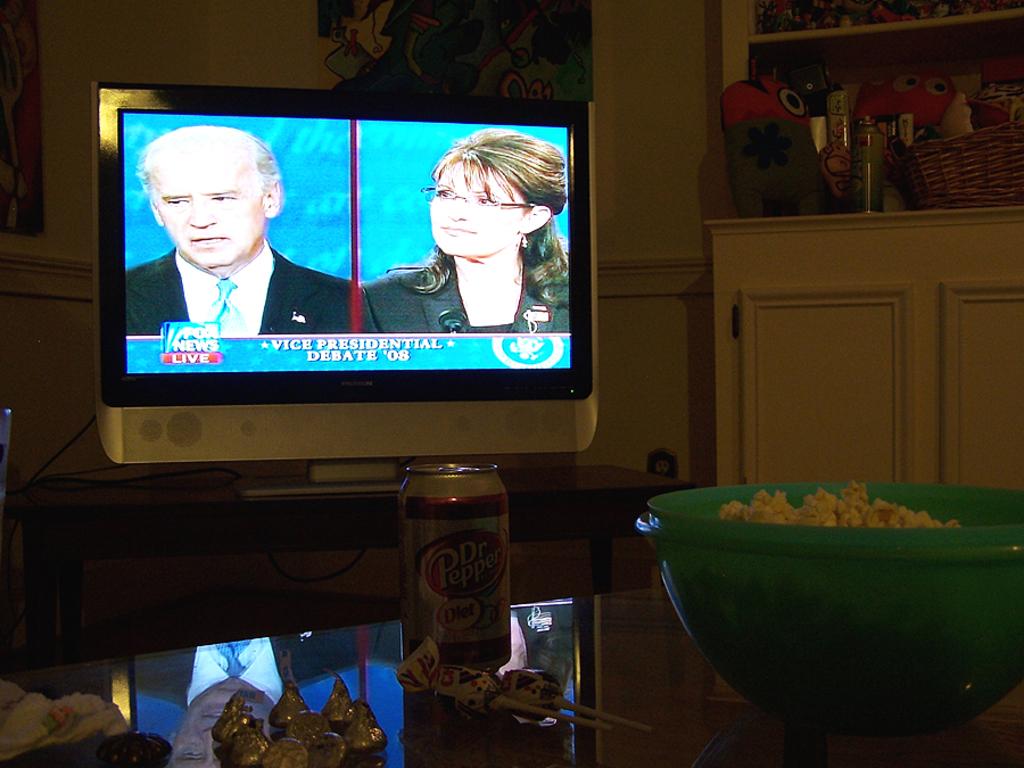Which station is this?
Provide a short and direct response. Fox news. What brand of soda is on the table?
Provide a succinct answer. Dr pepper. 